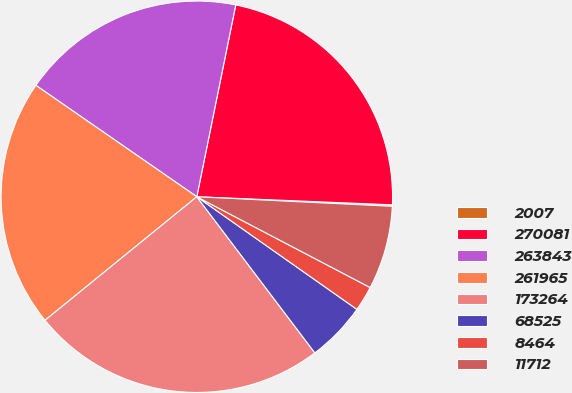Convert chart to OTSL. <chart><loc_0><loc_0><loc_500><loc_500><pie_chart><fcel>2007<fcel>270081<fcel>263843<fcel>261965<fcel>173264<fcel>68525<fcel>8464<fcel>11712<nl><fcel>0.12%<fcel>22.47%<fcel>18.55%<fcel>20.51%<fcel>24.43%<fcel>4.94%<fcel>2.08%<fcel>6.9%<nl></chart> 